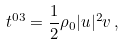Convert formula to latex. <formula><loc_0><loc_0><loc_500><loc_500>t ^ { 0 3 } = \frac { 1 } { 2 } \rho _ { 0 } | u | ^ { 2 } v \, ,</formula> 